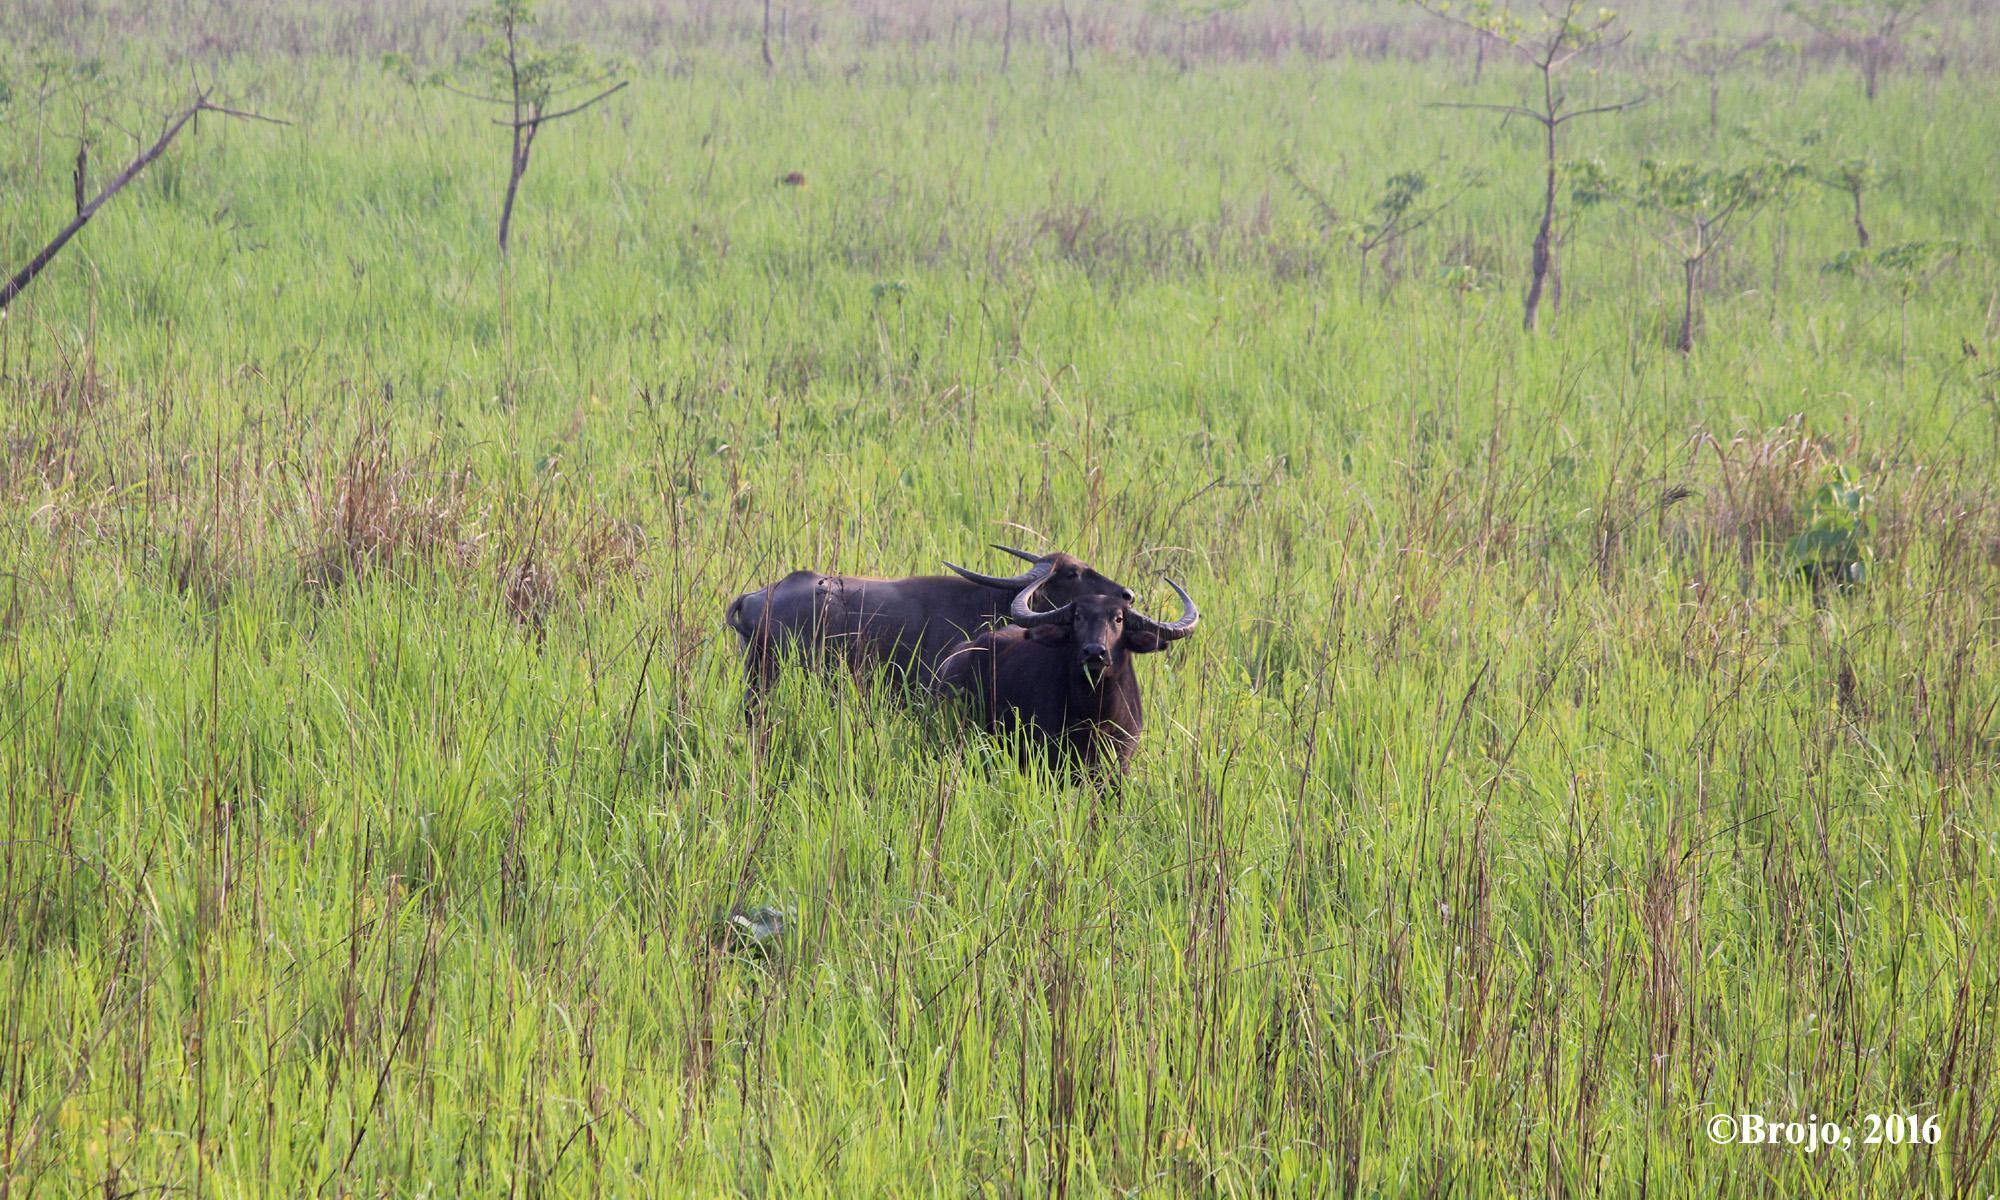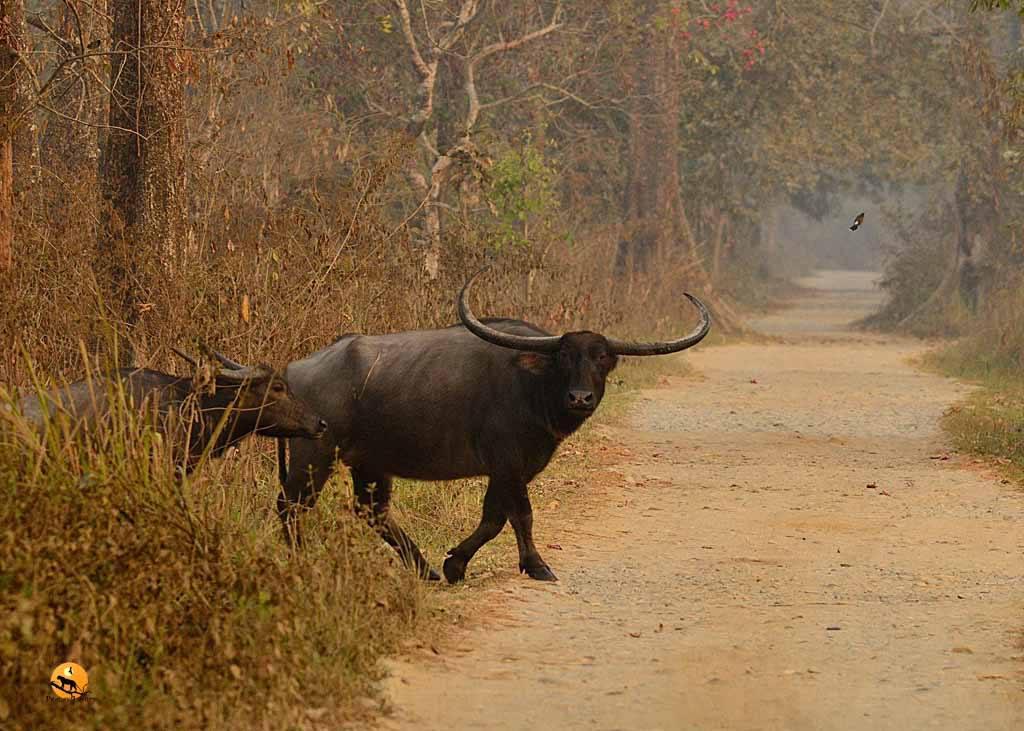The first image is the image on the left, the second image is the image on the right. Evaluate the accuracy of this statement regarding the images: "The left image contains one water buffalo looking directly at the camera, and the right image includes a water bufflao with a cord threaded through its nose.". Is it true? Answer yes or no. No. The first image is the image on the left, the second image is the image on the right. Considering the images on both sides, is "there is at least on animal standing on a path" valid? Answer yes or no. Yes. 